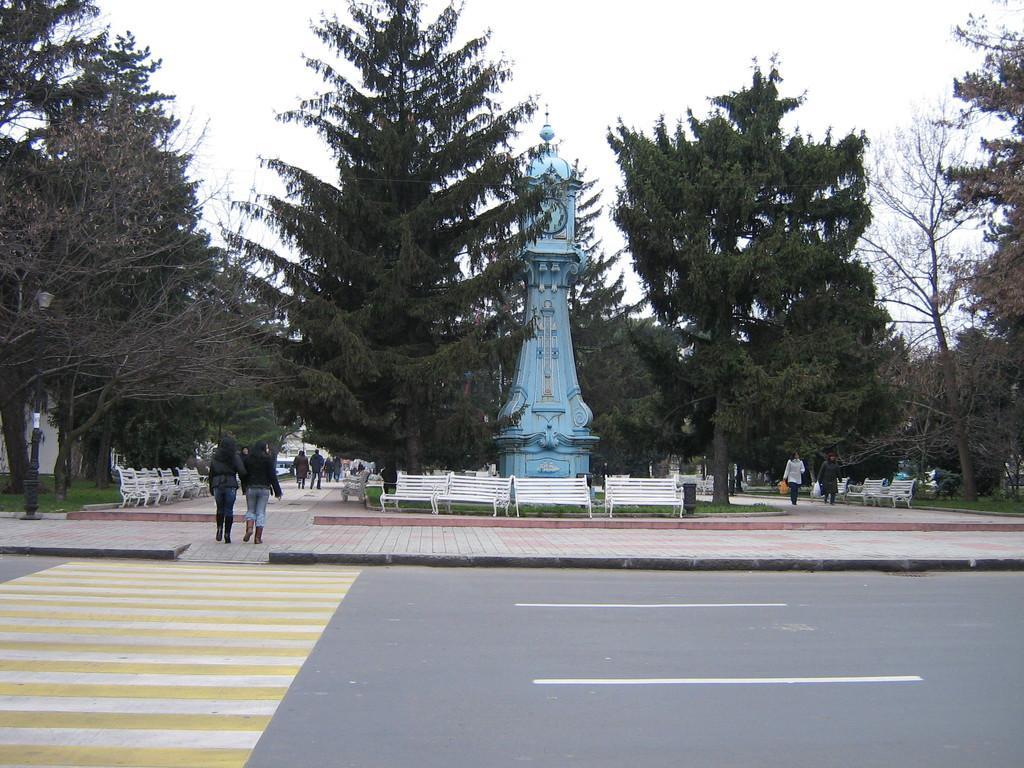How would you summarize this image in a sentence or two? In this picture I can see group of people standing, there are plants, benches, trees, there is a clock tower, and in the background there is sky. 